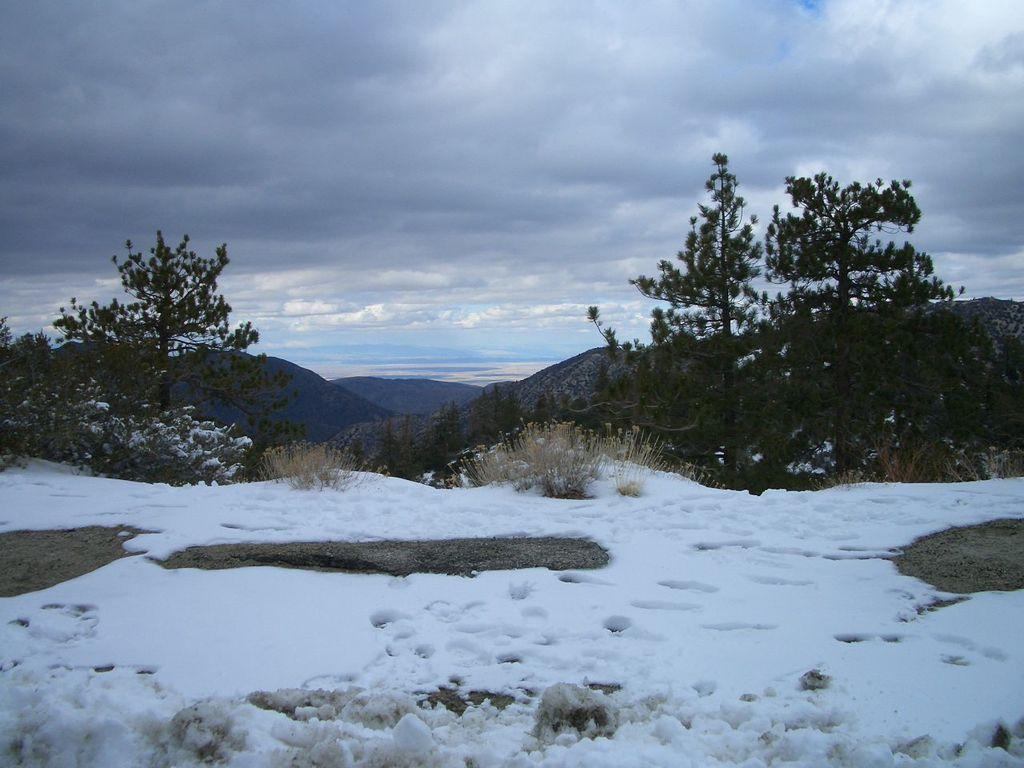Can you describe this image briefly? In this image I can see the snow. In the background I can see few plants, mountains and the sky is in white and blue color. 